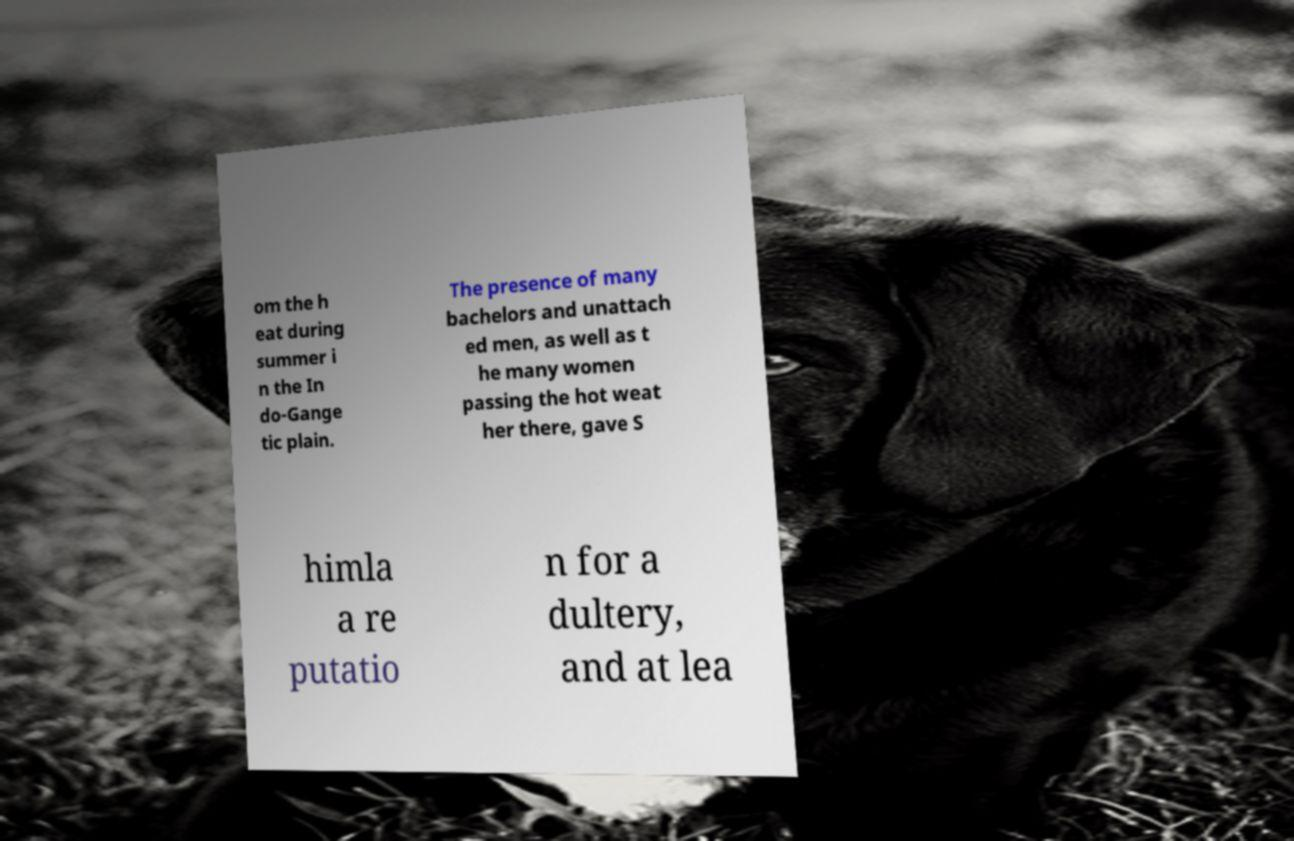There's text embedded in this image that I need extracted. Can you transcribe it verbatim? om the h eat during summer i n the In do-Gange tic plain. The presence of many bachelors and unattach ed men, as well as t he many women passing the hot weat her there, gave S himla a re putatio n for a dultery, and at lea 